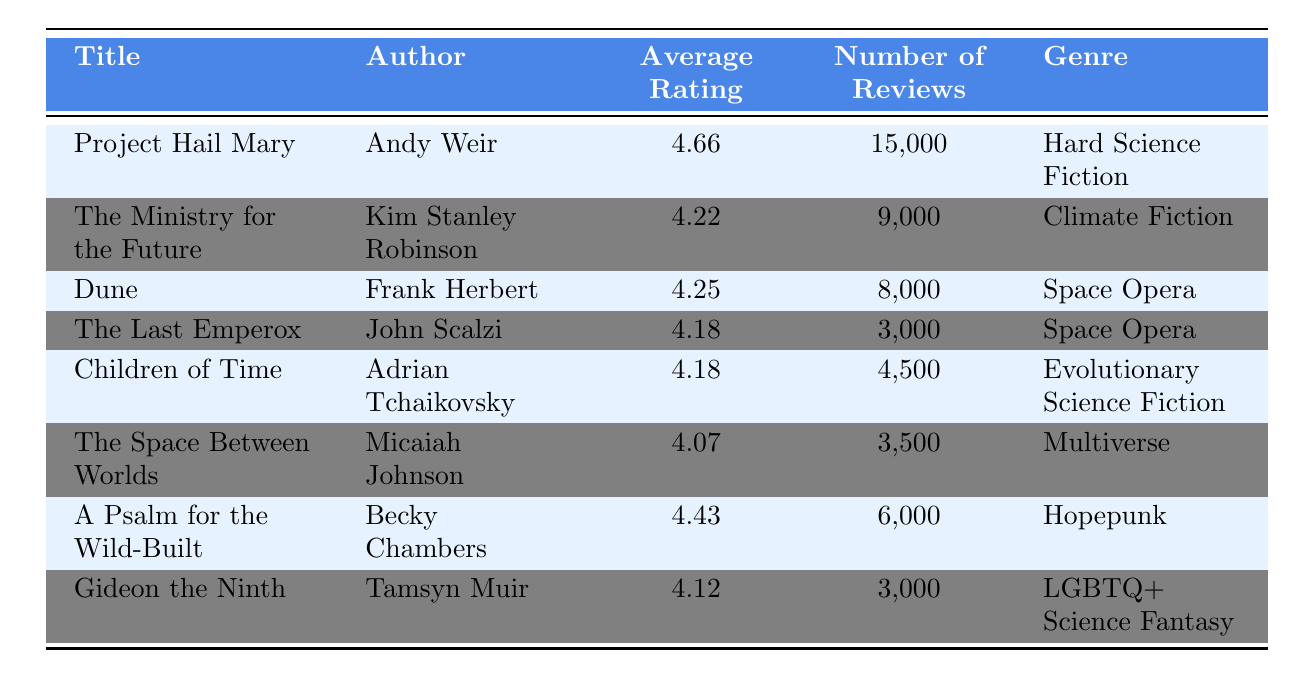What is the title with the highest average rating? The title with the highest average rating is found by examining the "Average Rating" column. The highest value is 4.66, which corresponds to the title "Project Hail Mary."
Answer: Project Hail Mary How many reviews does "The Last Emperox" have? The number of reviews for "The Last Emperox" is directly listed in the "Number of Reviews" column next to the title. It shows 3,000 reviews.
Answer: 3,000 What is the average rating of books in the Space Opera genre? To find the average rating for the Space Opera genre, we take the two books listed: "Dune" with a rating of 4.25 and "The Last Emperox" with a rating of 4.18. We calculate the average: (4.25 + 4.18) / 2 = 4.215.
Answer: 4.215 Does "A Psalm for the Wild-Built" have more reviews than "Gideon the Ninth"? By comparing the number of reviews in the respective "Number of Reviews" columns, "A Psalm for the Wild-Built" has 6,000 reviews and "Gideon the Ninth" has 3,000 reviews. Since 6,000 is greater than 3,000, the statement is true.
Answer: Yes What is the total number of reviews for books authored by Frank Herbert and Andy Weir? We identify the number of reviews for each author: Frank Herbert's "Dune" has 8,000 reviews, and Andy Weir's "Project Hail Mary" has 15,000 reviews. We sum these two values: 8,000 + 15,000 = 23,000.
Answer: 23,000 What genre does "Children of Time" belong to? "Children of Time" can be determined by looking at the genre column next to this title in the table, which states it falls under "Evolutionary Science Fiction."
Answer: Evolutionary Science Fiction Is the average rating for "The Ministry for the Future" above 4.0? We can check the average rating for "The Ministry for the Future" in the "Average Rating" column, which is 4.22. Since 4.22 is greater than 4.0, the statement is true.
Answer: Yes Which book has the least number of reviews, and how many does it have? To find the book with the least number of reviews, we check the "Number of Reviews" column for the lowest value. "The Last Emperox" has the least with 3,000 reviews.
Answer: The Last Emperox, 3,000 